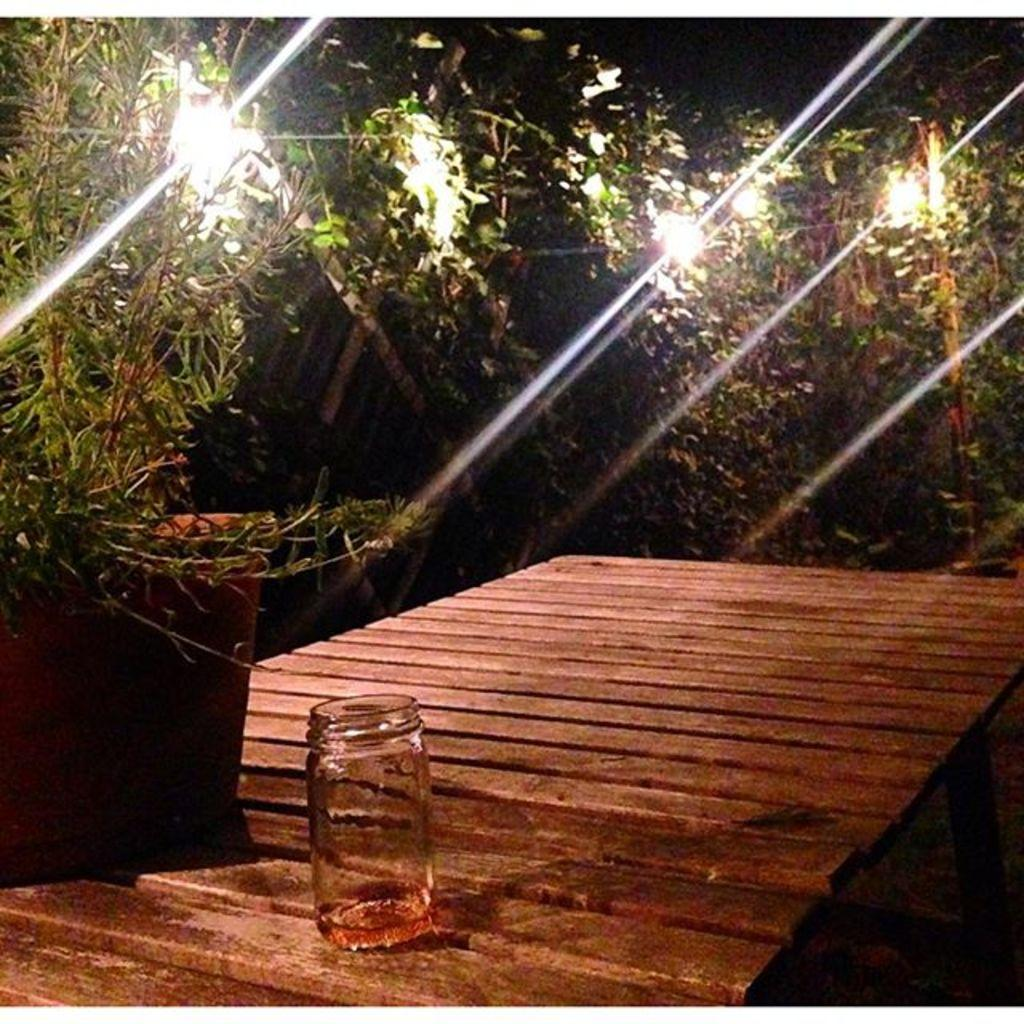What type of vegetation is present in the image? There are trees in the image. What is placed between the trees? There are lights between the trees. Is there any greenery in a container in the image? Yes, there is a flower pot with a plant in the image. What type of furniture is visible in the image? There is a table in the image. What object is placed on the table? There is a glass jar on the table. What day of the week is depicted in the image? The image does not depict a specific day of the week; it only shows trees, lights, a flower pot, a table, and a glass jar. Is there an addition to the image that is not mentioned in the facts? No, all the elements mentioned in the conversation are present in the image based on the provided facts. 